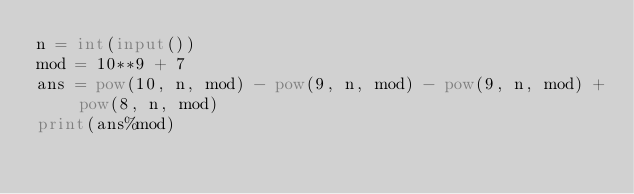Convert code to text. <code><loc_0><loc_0><loc_500><loc_500><_Python_>n = int(input())
mod = 10**9 + 7
ans = pow(10, n, mod) - pow(9, n, mod) - pow(9, n, mod) + pow(8, n, mod)
print(ans%mod)</code> 